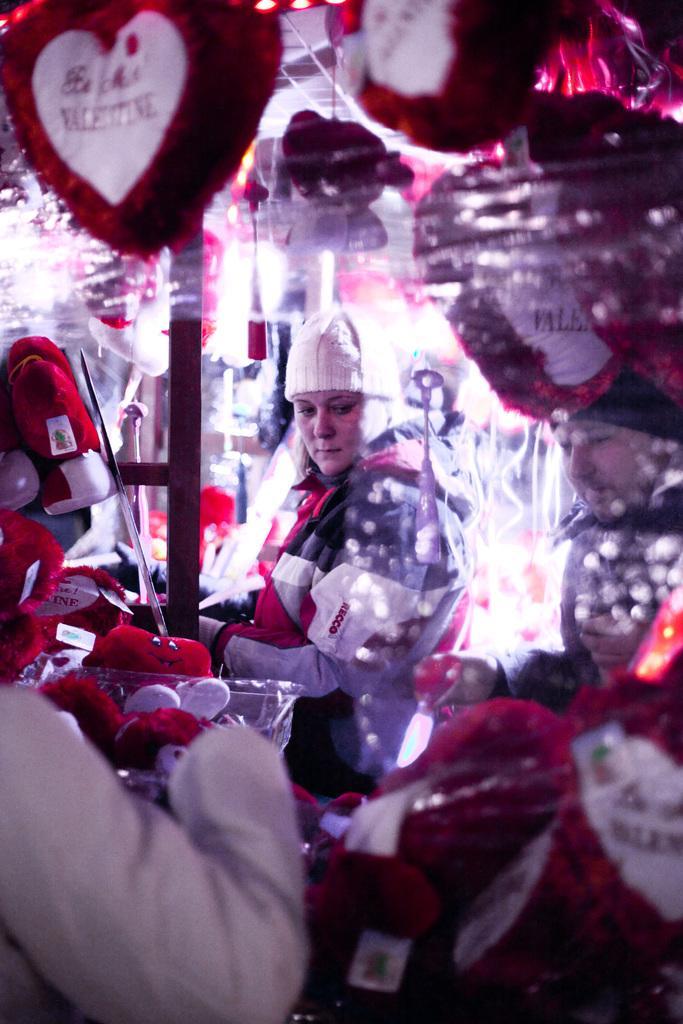Please provide a concise description of this image. In this image there is a woman and a man standing. Around them there are many toys in the shape of a heart. There is text on the toys. 